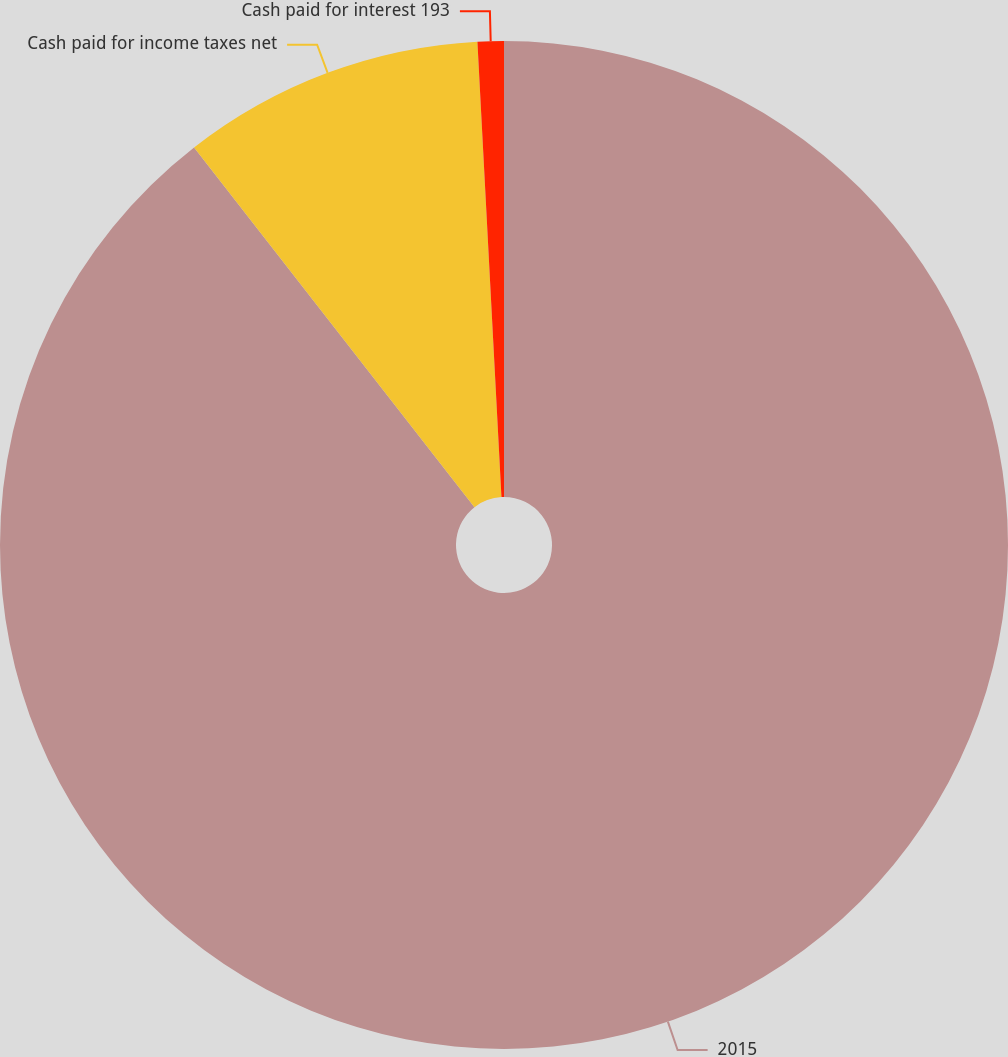<chart> <loc_0><loc_0><loc_500><loc_500><pie_chart><fcel>2015<fcel>Cash paid for income taxes net<fcel>Cash paid for interest 193<nl><fcel>89.45%<fcel>9.7%<fcel>0.84%<nl></chart> 